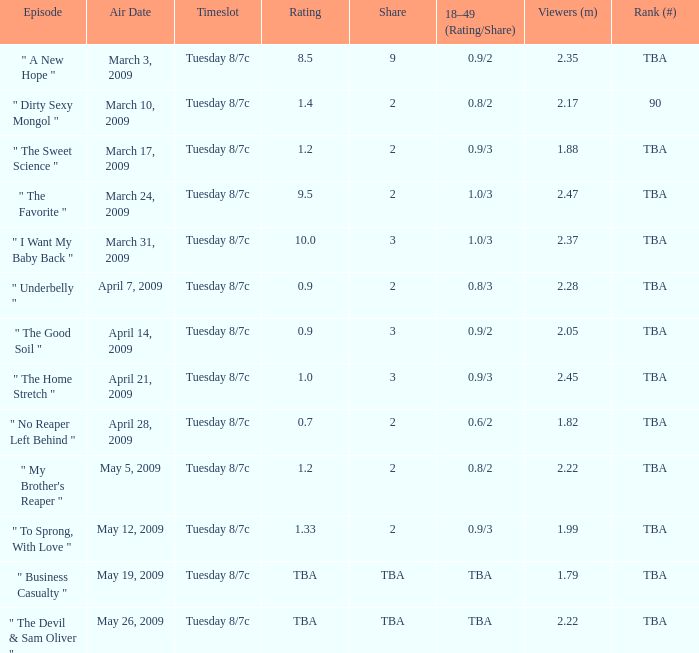8/3? 2.0. 